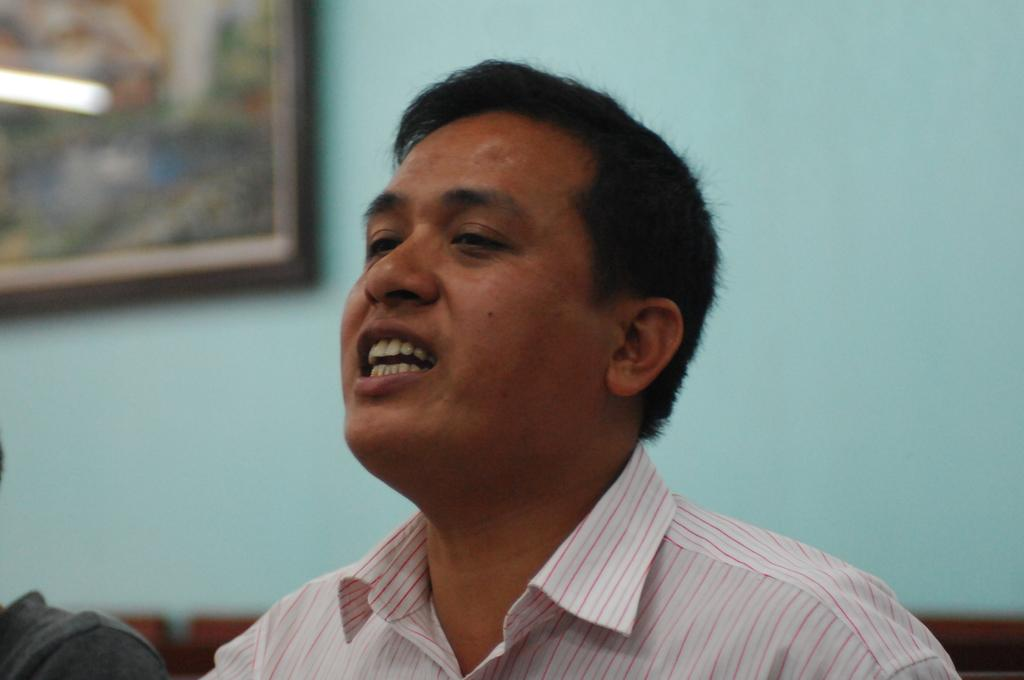What is the main subject of the image? The main subject of the image is a man. What is the man doing in the image? The man is talking, with his mouth open. What can be seen in the background of the image? There is a wall in the background of the image. Are there any objects on the wall? Yes, there is a photo frame on the wall. What type of jar is being used during the meeting in the image? There is no jar or meeting present in the image; it features a man talking with his mouth open and a photo frame on the wall. 